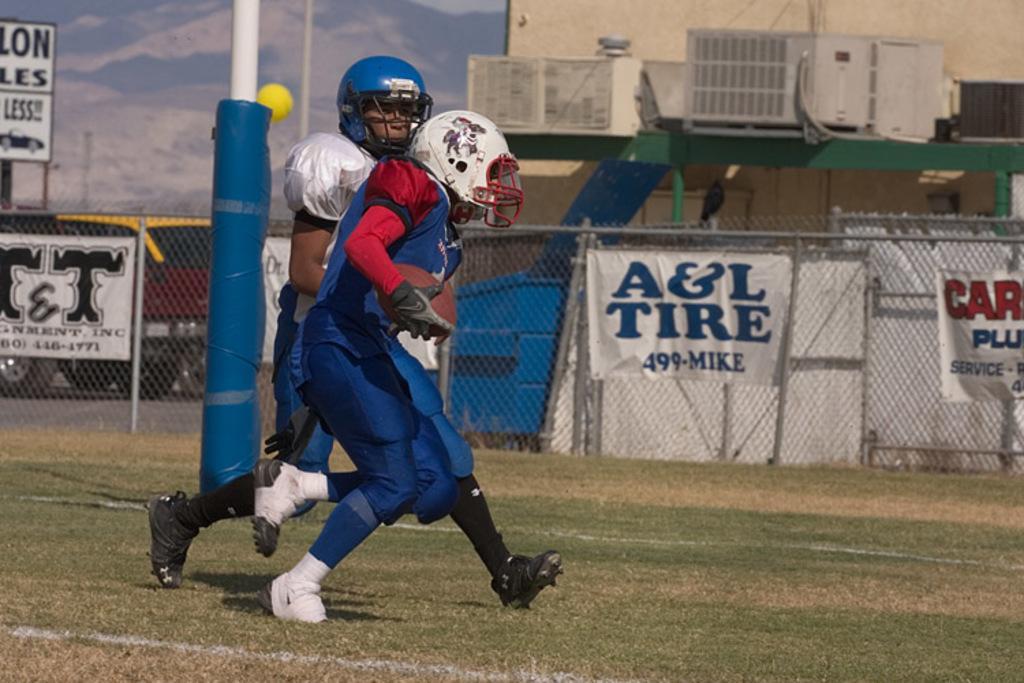Could you give a brief overview of what you see in this image? The man in blue T-shirt who is wearing a white helmet is holding a football in his hand. Behind him, we see a man in white T-shirt is running behind the man. Behind them, we see a pole and behind that, we see a fence. We see white banners with some text written on it. On the right side, we see a building. On the left side, we see a board with some text written on it. At the top of the picture, we see the sky. 